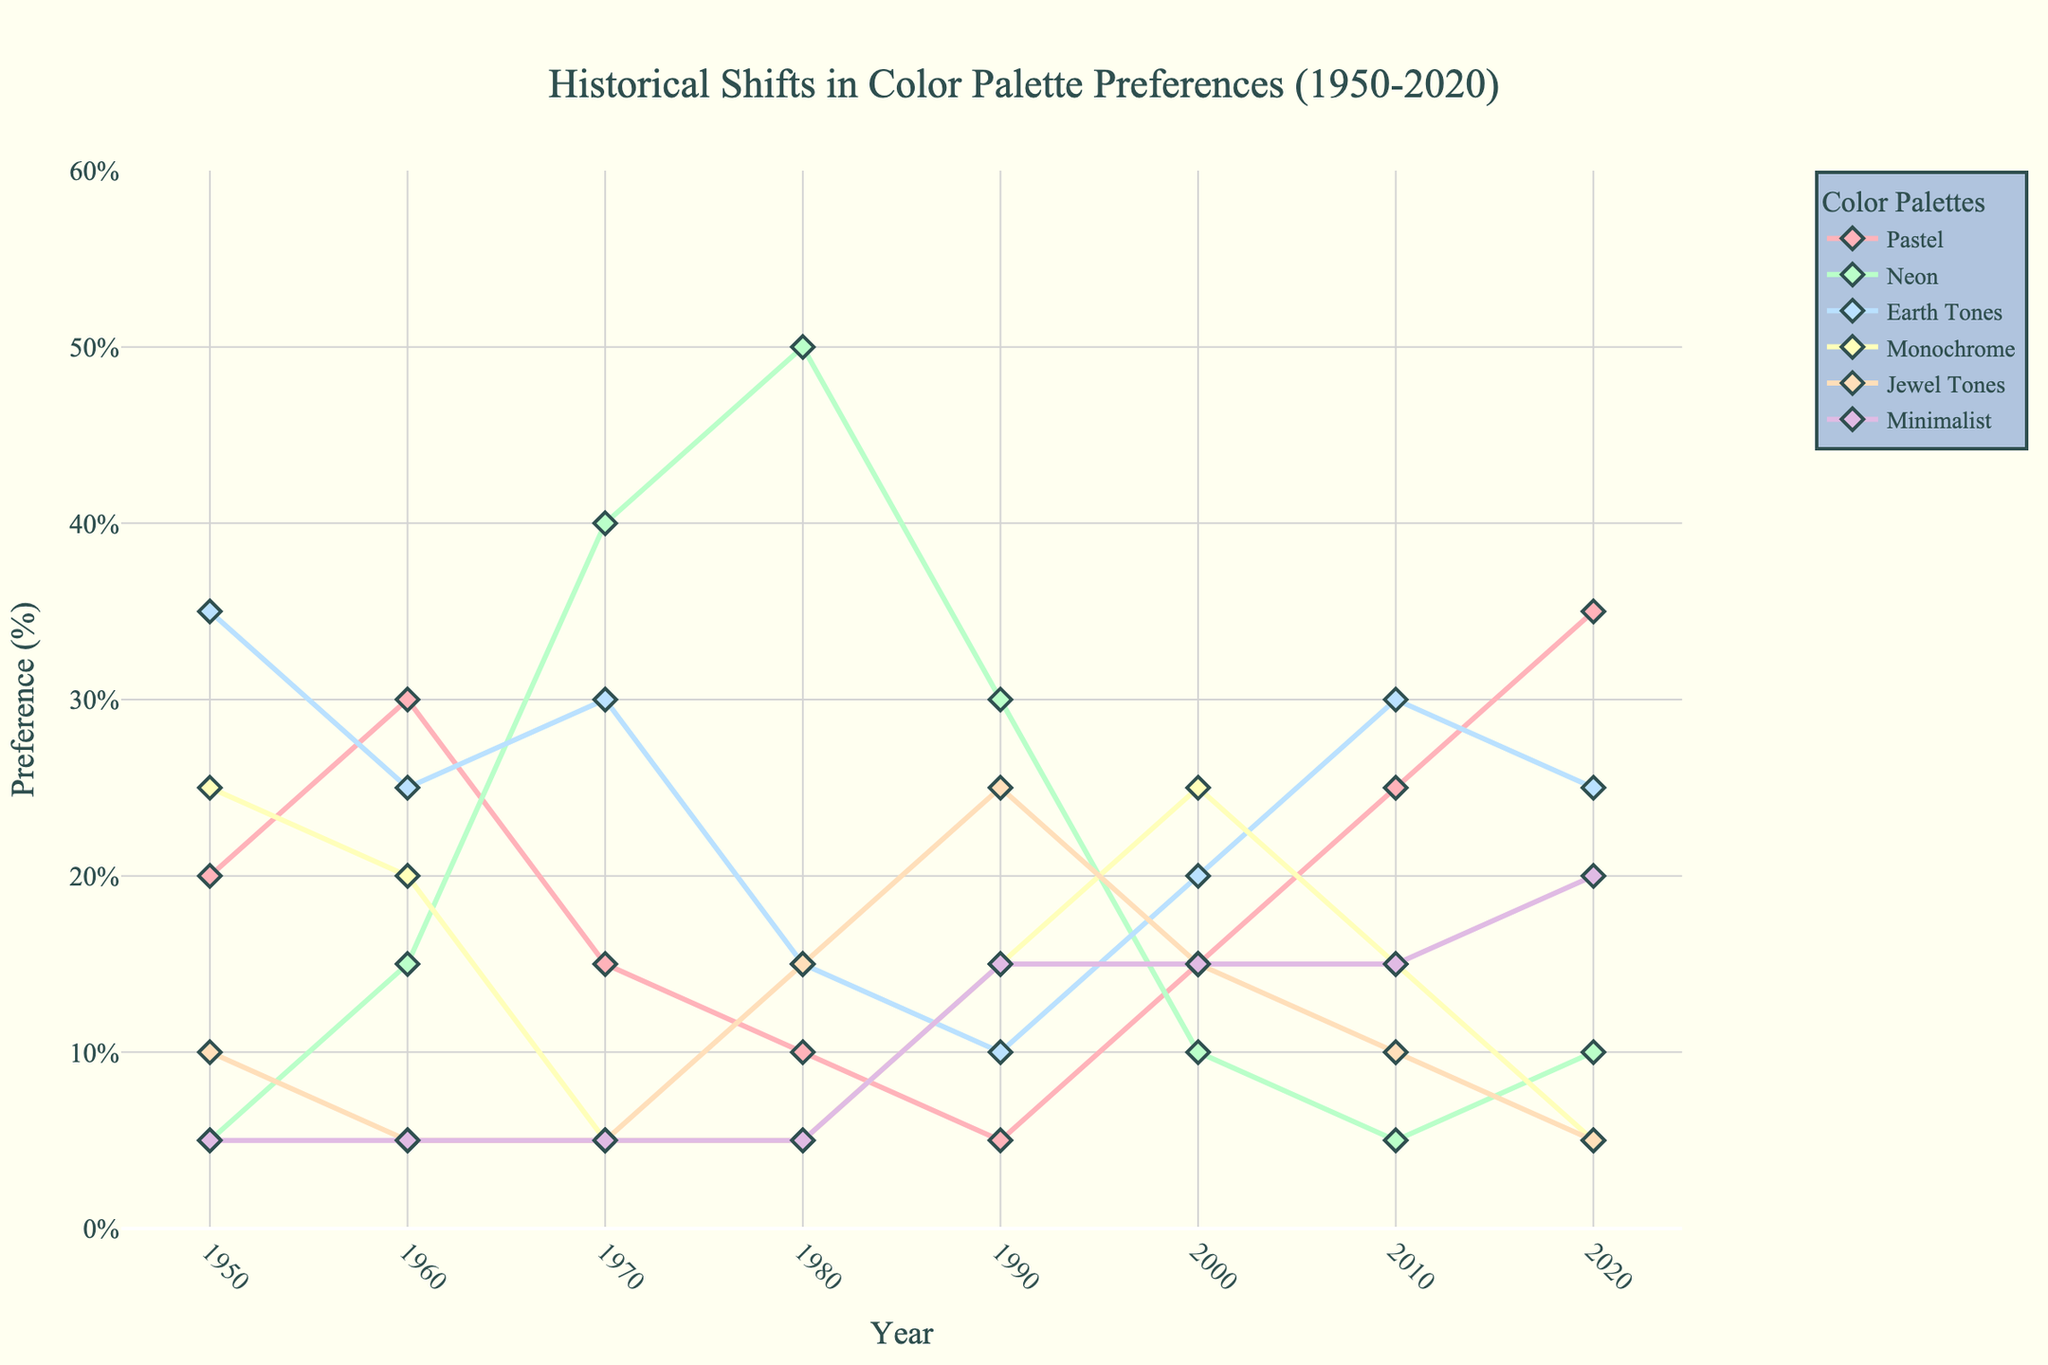What trend is observed in the preference for pastel colors from 1950 to 2020? The preference for pastel colors shows a steady increase over time. Starting at 20% in 1950, it rises consistently, reaching 35% by 2020.
Answer: Steady increase Between which years did neon colors reach their peak preference? Neon colors peaked in the 1980s with a preference of 50%. This can be seen as the highest point on the line representing neon colors.
Answer: 1980s Which two color palettes had the highest preference in 2020? In 2020, pastel colors had the highest preference at 35%, followed by minimalist colors at 20%.
Answer: Pastel colors and Minimalist colors How did the preference for earth tones compare in the 1950s and 2010s? Earth tones had a preference of 35% in the 1950s and 30% in the 2010s. To compare, 35% - 30% = 5%. Therefore, the preference decreased by 5%.
Answer: Decreased by 5% Between which years did the preference for monochrome remain constant? Monochrome preference remained constant at 5% between 1970 and 1980, and then again between 2010 and 2020.
Answer: 2010-2020 What is the average preference for jewel tones over the decades presented? To find the average, sum the preferences for each decade: 10 (1950s) + 5 (1960s) + 5 (1970s) + 15 (1980s) + 25 (1990s) + 15 (2000s) + 10 (2010s) + 5 (2020s) = 90. Divide by the number of decades: 90 / 8 = 11.25%.
Answer: 11.25% Which color palette saw the biggest drop in popularity from the 1980s to the 1990s? Neon colors experienced the biggest drop, decreasing from 50% in the 1980s to 30% in the 1990s, a drop of 20%.
Answer: Neon colors Was there any color palette that had a consistent preference percentage every decade? Minimalist colors remained consistent at 5% for several decades (1950s, 1960s, 1970s, 1980s, and 2010s) but varied in others, thus no color had a perfectly consistent percentage every decade.
Answer: No Which color palette had the third highest preference in the 1990s? In the 1990s, the third highest preference was held by minimalist colors at 15%.
Answer: Minimalist colors 